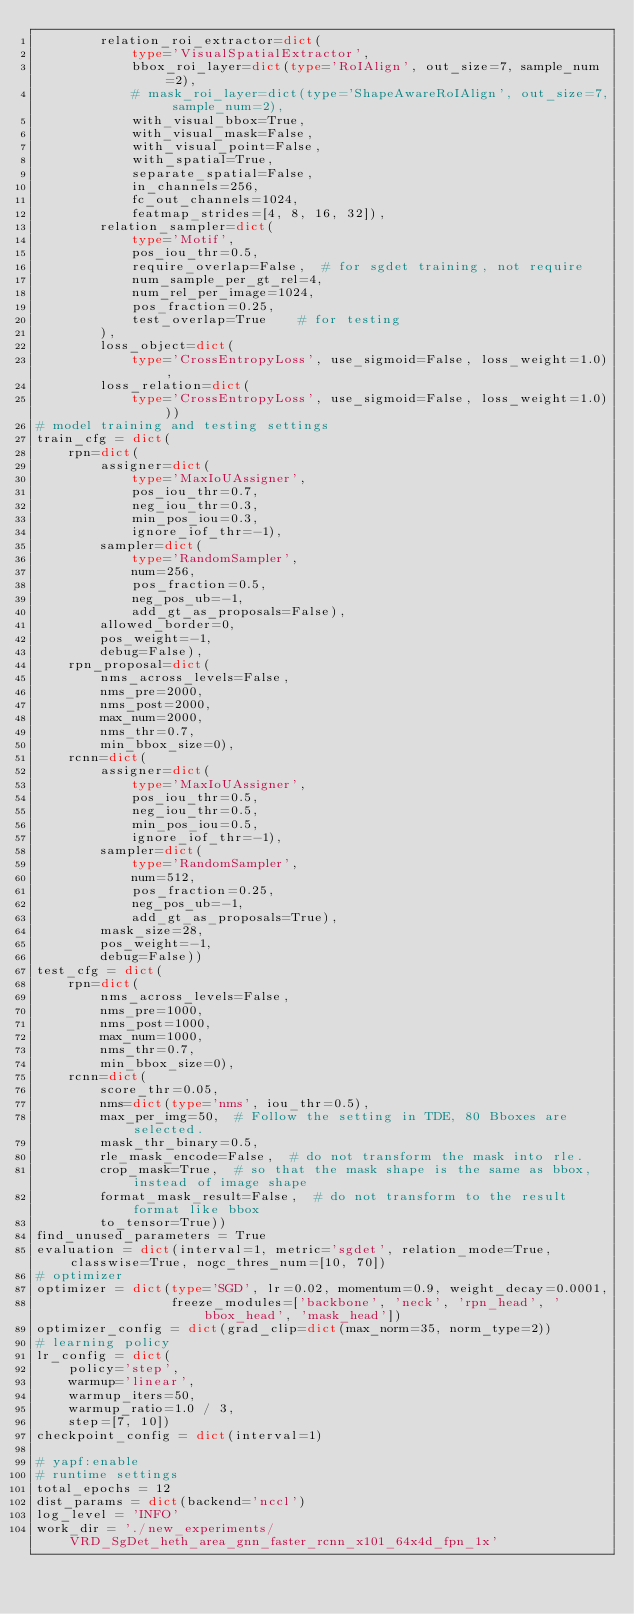Convert code to text. <code><loc_0><loc_0><loc_500><loc_500><_Python_>        relation_roi_extractor=dict(
            type='VisualSpatialExtractor',
            bbox_roi_layer=dict(type='RoIAlign', out_size=7, sample_num=2),
            # mask_roi_layer=dict(type='ShapeAwareRoIAlign', out_size=7, sample_num=2),
            with_visual_bbox=True,
            with_visual_mask=False,
            with_visual_point=False,
            with_spatial=True,
            separate_spatial=False,
            in_channels=256,
            fc_out_channels=1024,
            featmap_strides=[4, 8, 16, 32]),
        relation_sampler=dict(
            type='Motif',
            pos_iou_thr=0.5,
            require_overlap=False,  # for sgdet training, not require
            num_sample_per_gt_rel=4,
            num_rel_per_image=1024,
            pos_fraction=0.25,
            test_overlap=True    # for testing
        ),
        loss_object=dict(
            type='CrossEntropyLoss', use_sigmoid=False, loss_weight=1.0),
        loss_relation=dict(
            type='CrossEntropyLoss', use_sigmoid=False, loss_weight=1.0)))
# model training and testing settings
train_cfg = dict(
    rpn=dict(
        assigner=dict(
            type='MaxIoUAssigner',
            pos_iou_thr=0.7,
            neg_iou_thr=0.3,
            min_pos_iou=0.3,
            ignore_iof_thr=-1),
        sampler=dict(
            type='RandomSampler',
            num=256,
            pos_fraction=0.5,
            neg_pos_ub=-1,
            add_gt_as_proposals=False),
        allowed_border=0,
        pos_weight=-1,
        debug=False),
    rpn_proposal=dict(
        nms_across_levels=False,
        nms_pre=2000,
        nms_post=2000,
        max_num=2000,
        nms_thr=0.7,
        min_bbox_size=0),
    rcnn=dict(
        assigner=dict(
            type='MaxIoUAssigner',
            pos_iou_thr=0.5,
            neg_iou_thr=0.5,
            min_pos_iou=0.5,
            ignore_iof_thr=-1),
        sampler=dict(
            type='RandomSampler',
            num=512,
            pos_fraction=0.25,
            neg_pos_ub=-1,
            add_gt_as_proposals=True),
        mask_size=28,
        pos_weight=-1,
        debug=False))
test_cfg = dict(
    rpn=dict(
        nms_across_levels=False,
        nms_pre=1000,
        nms_post=1000,
        max_num=1000,
        nms_thr=0.7,
        min_bbox_size=0),
    rcnn=dict(
        score_thr=0.05,
        nms=dict(type='nms', iou_thr=0.5),
        max_per_img=50,  # Follow the setting in TDE, 80 Bboxes are selected.
        mask_thr_binary=0.5,
        rle_mask_encode=False,  # do not transform the mask into rle.
        crop_mask=True,  # so that the mask shape is the same as bbox, instead of image shape
        format_mask_result=False,  # do not transform to the result format like bbox
        to_tensor=True))
find_unused_parameters = True
evaluation = dict(interval=1, metric='sgdet', relation_mode=True, classwise=True, nogc_thres_num=[10, 70])
# optimizer
optimizer = dict(type='SGD', lr=0.02, momentum=0.9, weight_decay=0.0001,
                 freeze_modules=['backbone', 'neck', 'rpn_head', 'bbox_head', 'mask_head'])
optimizer_config = dict(grad_clip=dict(max_norm=35, norm_type=2))
# learning policy
lr_config = dict(
    policy='step',
    warmup='linear',
    warmup_iters=50,
    warmup_ratio=1.0 / 3,
    step=[7, 10])
checkpoint_config = dict(interval=1)

# yapf:enable
# runtime settings
total_epochs = 12
dist_params = dict(backend='nccl')
log_level = 'INFO'
work_dir = './new_experiments/VRD_SgDet_heth_area_gnn_faster_rcnn_x101_64x4d_fpn_1x'</code> 